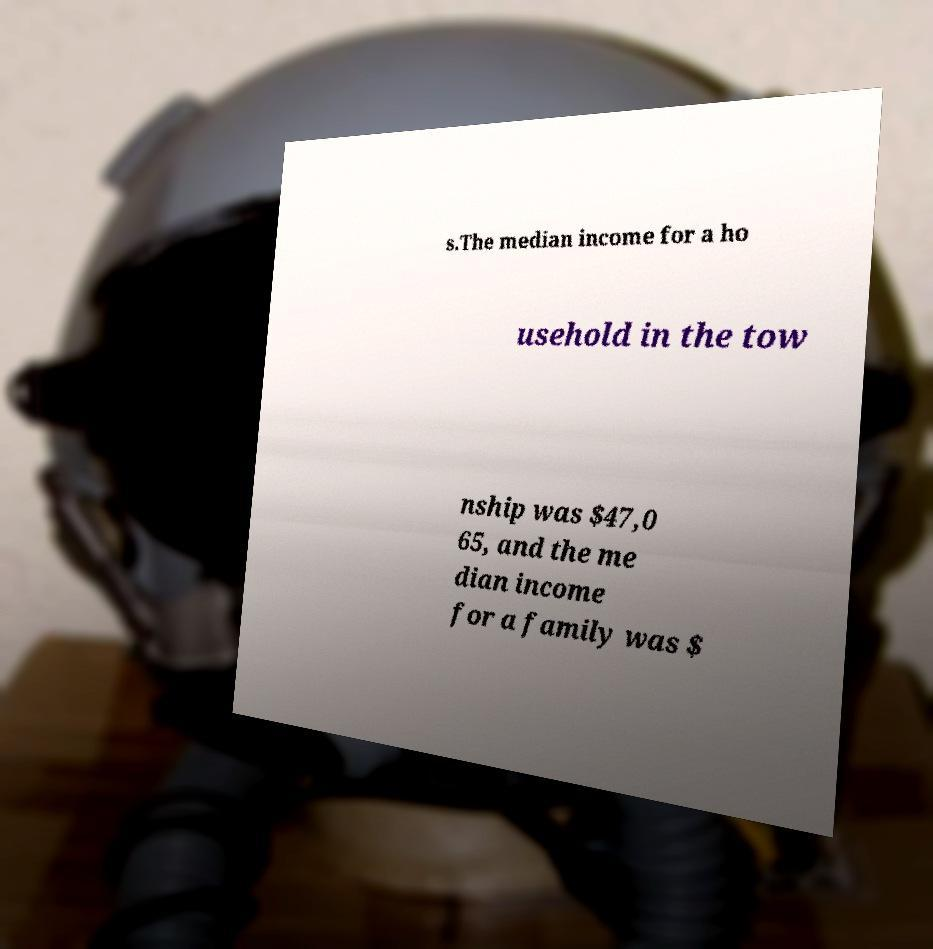There's text embedded in this image that I need extracted. Can you transcribe it verbatim? s.The median income for a ho usehold in the tow nship was $47,0 65, and the me dian income for a family was $ 